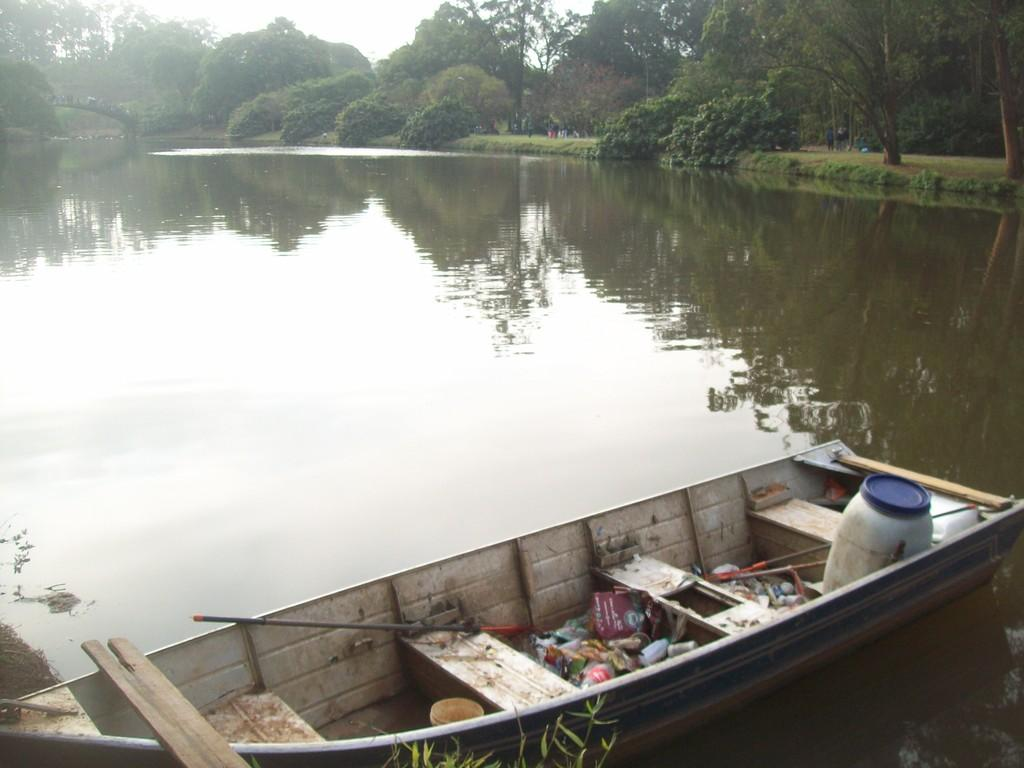What is the main subject of the image? The main subject of the image is a boat. Where is the boat located? The boat is on the water. What musical instrument can be seen on the boat? There is a drum on the boat. What else can be seen on the boat besides the drum? There are other objects on the boat. What can be seen in the background of the image? There are trees and the sky visible in the background of the image. How many beggars are visible on the boat in the image? There are no beggars present in the image; it features a boat with a drum and other objects. What type of quiver is used by the person playing the drum on the boat? There is no person playing the drum or any quiver visible in the image. 